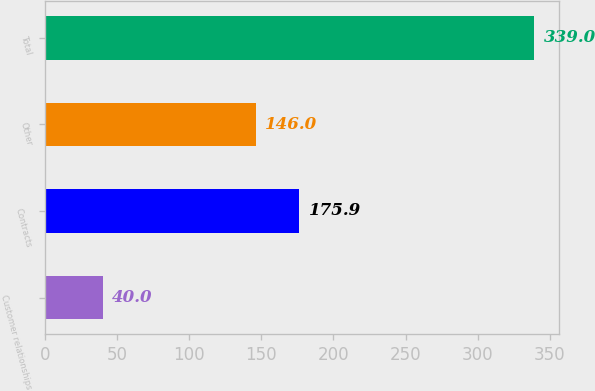Convert chart. <chart><loc_0><loc_0><loc_500><loc_500><bar_chart><fcel>Customer relationships<fcel>Contracts<fcel>Other<fcel>Total<nl><fcel>40<fcel>175.9<fcel>146<fcel>339<nl></chart> 